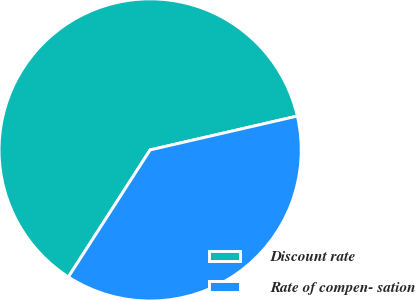Convert chart to OTSL. <chart><loc_0><loc_0><loc_500><loc_500><pie_chart><fcel>Discount rate<fcel>Rate of compen- sation<nl><fcel>62.3%<fcel>37.7%<nl></chart> 